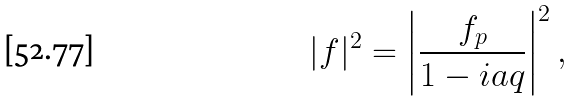Convert formula to latex. <formula><loc_0><loc_0><loc_500><loc_500>| f | ^ { 2 } = \left | \frac { f _ { p } } { 1 - i a q } \right | ^ { 2 } ,</formula> 